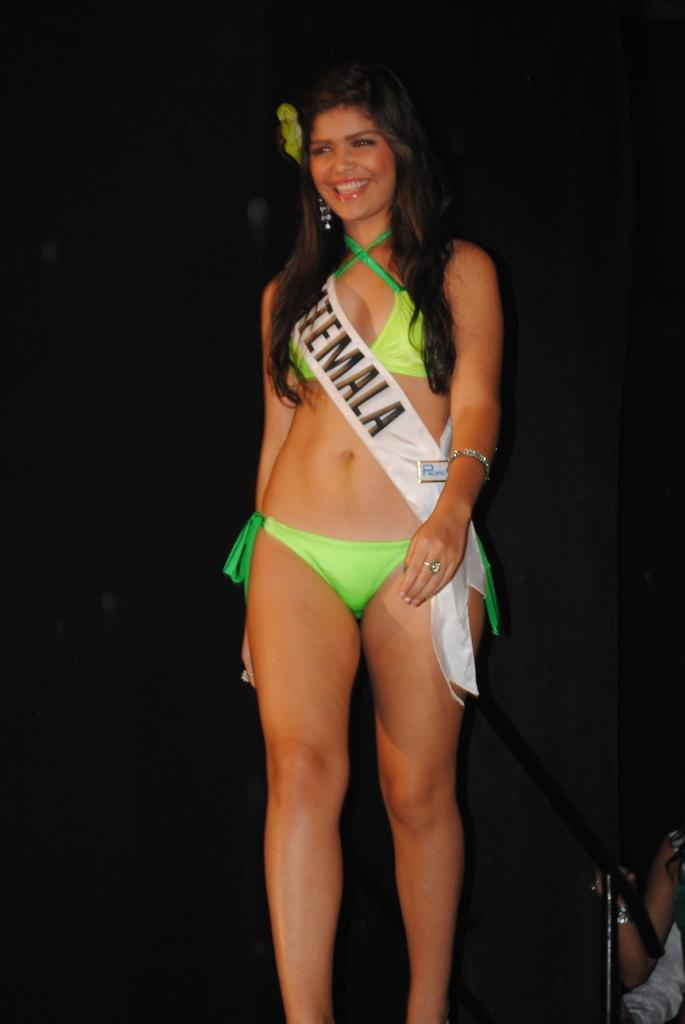Who is present in the image? There is a woman in the image. What is the woman wearing on her body? The woman is wearing a ribbon on her body. What is the woman's position in the image? The woman is standing on the floor. Can you describe the background of the image? There is a person in the background of the image. What type of toothpaste is the woman using in the image? There is no toothpaste present in the image, and the woman is not using any toothpaste. 